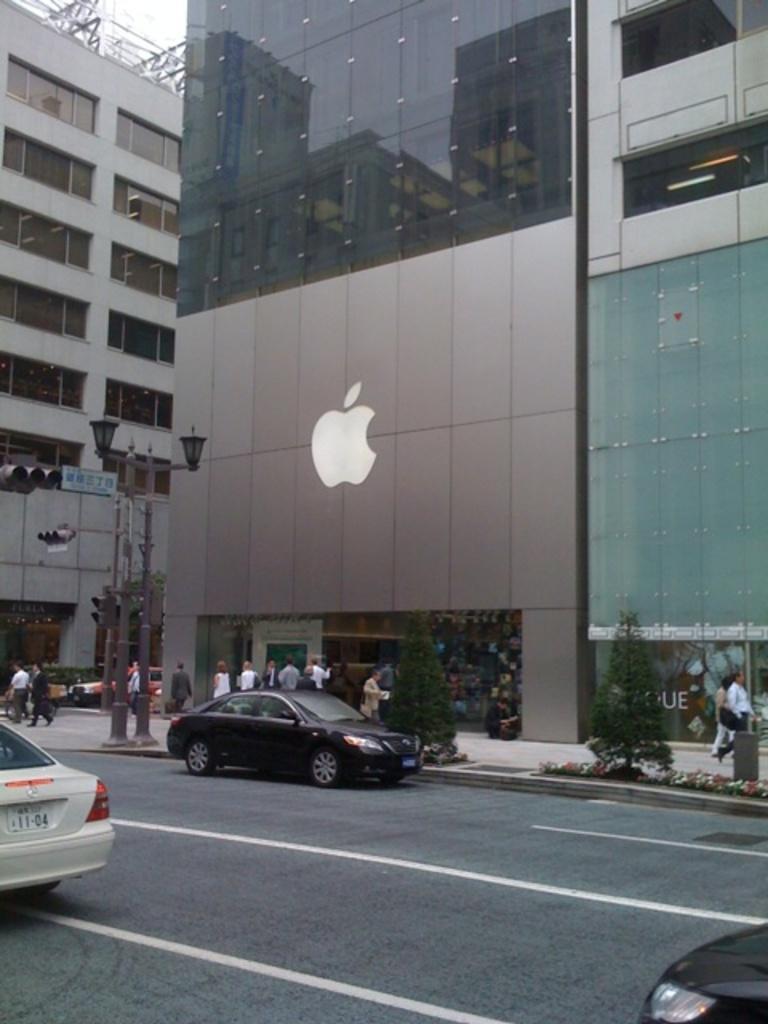Can you describe this image briefly? There is an apple organization, many people were walking around the organization and there is a tree on the footpath. In front of the tree there are few vehicles moving on the road, on the right side there is traffic signal pole and also a street light. 